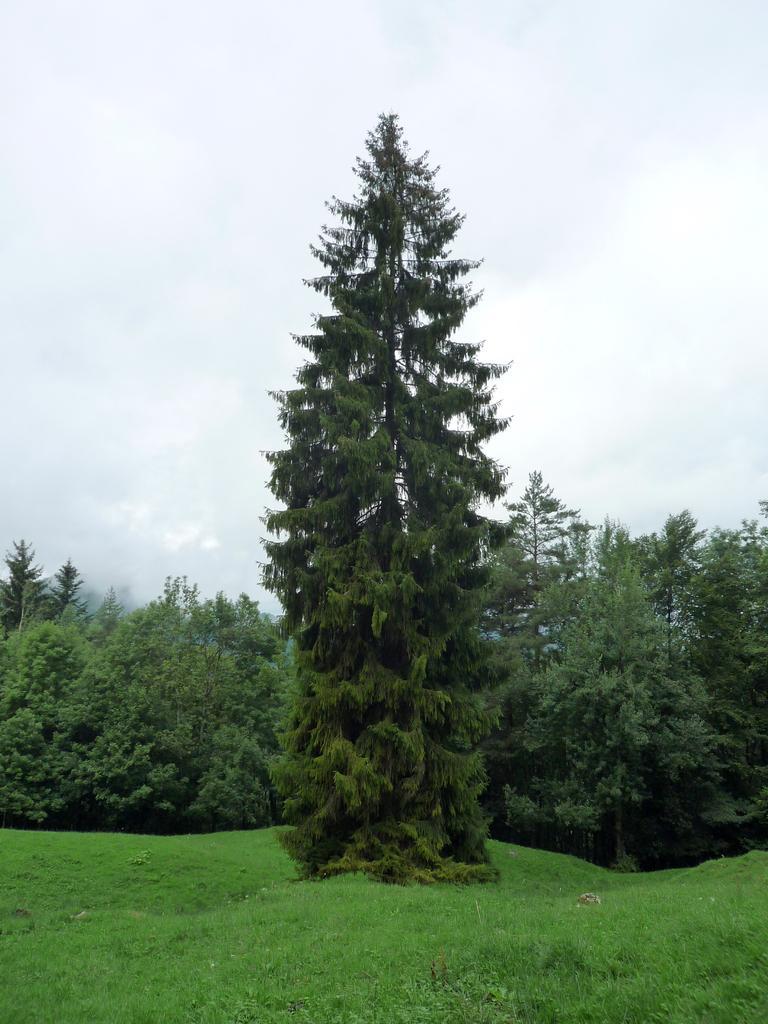How would you summarize this image in a sentence or two? In this picture we can see trees are there. At the bottom of the image there is a ground. At the top of the image clouds are present in the sky. 